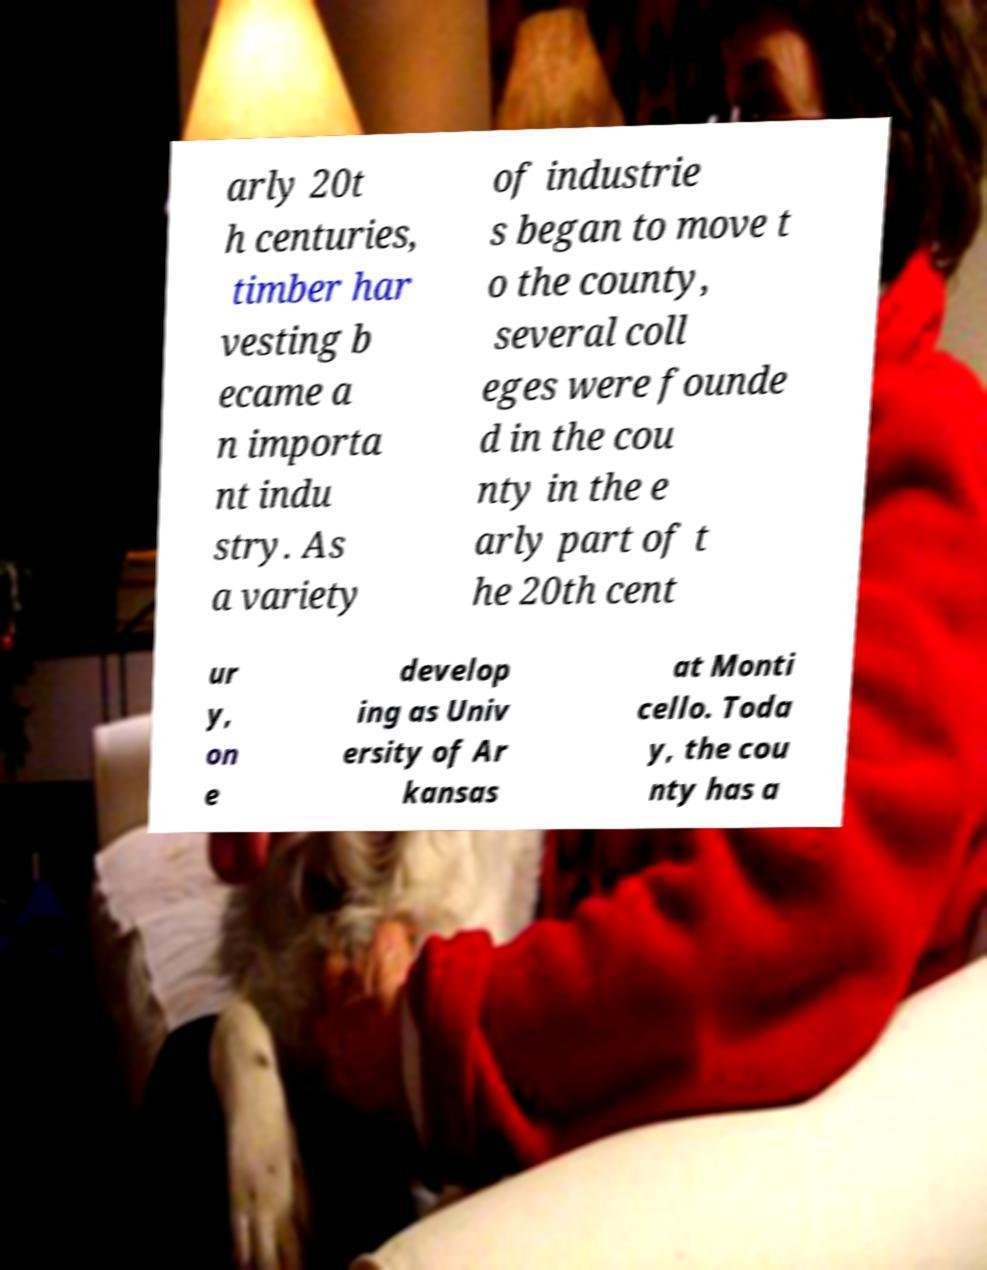Please read and relay the text visible in this image. What does it say? arly 20t h centuries, timber har vesting b ecame a n importa nt indu stry. As a variety of industrie s began to move t o the county, several coll eges were founde d in the cou nty in the e arly part of t he 20th cent ur y, on e develop ing as Univ ersity of Ar kansas at Monti cello. Toda y, the cou nty has a 